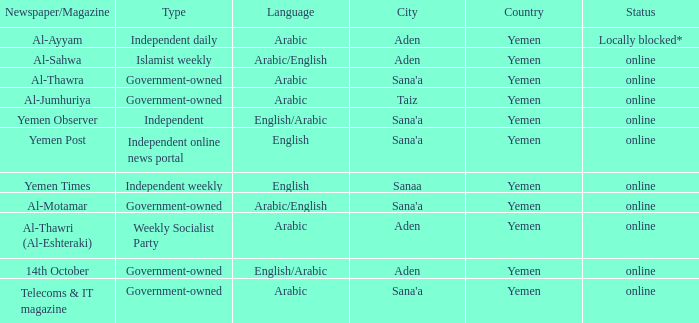What is Headquarter, when Type is Government-Owned, and when Newspaper/Magazine is Al-Jumhuriya? Taiz. 